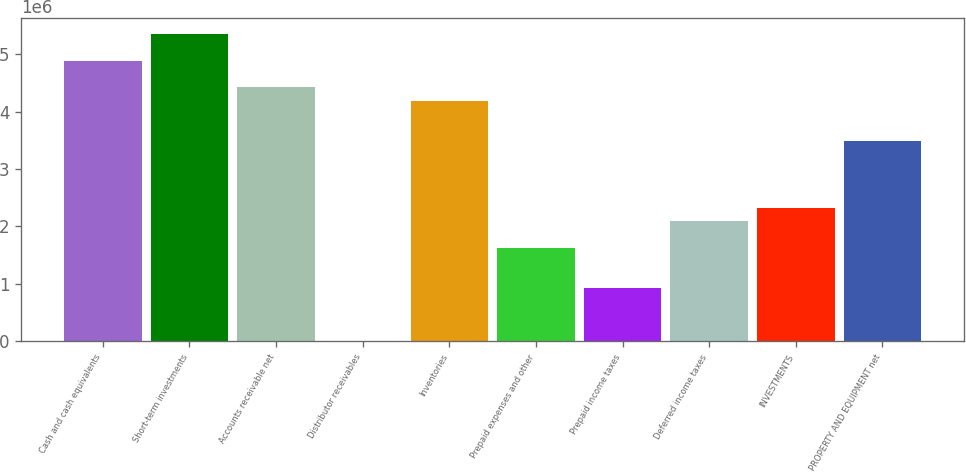<chart> <loc_0><loc_0><loc_500><loc_500><bar_chart><fcel>Cash and cash equivalents<fcel>Short-term investments<fcel>Accounts receivable net<fcel>Distributor receivables<fcel>Inventories<fcel>Prepaid expenses and other<fcel>Prepaid income taxes<fcel>Deferred income taxes<fcel>INVESTMENTS<fcel>PROPERTY AND EQUIPMENT net<nl><fcel>4.89346e+06<fcel>5.35946e+06<fcel>4.42747e+06<fcel>552<fcel>4.19448e+06<fcel>1.63152e+06<fcel>932535<fcel>2.09751e+06<fcel>2.33051e+06<fcel>3.49549e+06<nl></chart> 